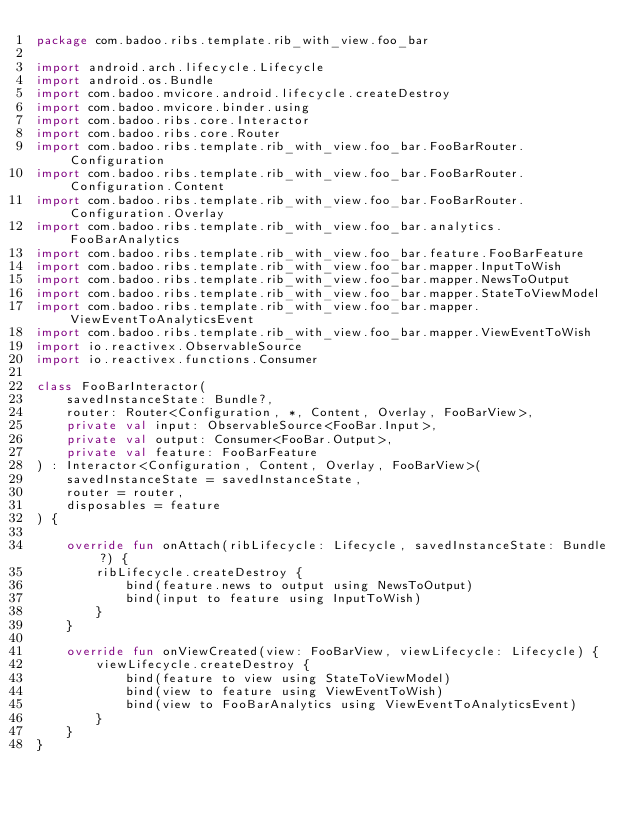Convert code to text. <code><loc_0><loc_0><loc_500><loc_500><_Kotlin_>package com.badoo.ribs.template.rib_with_view.foo_bar

import android.arch.lifecycle.Lifecycle
import android.os.Bundle
import com.badoo.mvicore.android.lifecycle.createDestroy
import com.badoo.mvicore.binder.using
import com.badoo.ribs.core.Interactor
import com.badoo.ribs.core.Router
import com.badoo.ribs.template.rib_with_view.foo_bar.FooBarRouter.Configuration
import com.badoo.ribs.template.rib_with_view.foo_bar.FooBarRouter.Configuration.Content
import com.badoo.ribs.template.rib_with_view.foo_bar.FooBarRouter.Configuration.Overlay
import com.badoo.ribs.template.rib_with_view.foo_bar.analytics.FooBarAnalytics
import com.badoo.ribs.template.rib_with_view.foo_bar.feature.FooBarFeature
import com.badoo.ribs.template.rib_with_view.foo_bar.mapper.InputToWish
import com.badoo.ribs.template.rib_with_view.foo_bar.mapper.NewsToOutput
import com.badoo.ribs.template.rib_with_view.foo_bar.mapper.StateToViewModel
import com.badoo.ribs.template.rib_with_view.foo_bar.mapper.ViewEventToAnalyticsEvent
import com.badoo.ribs.template.rib_with_view.foo_bar.mapper.ViewEventToWish
import io.reactivex.ObservableSource
import io.reactivex.functions.Consumer

class FooBarInteractor(
    savedInstanceState: Bundle?,
    router: Router<Configuration, *, Content, Overlay, FooBarView>,
    private val input: ObservableSource<FooBar.Input>,
    private val output: Consumer<FooBar.Output>,
    private val feature: FooBarFeature
) : Interactor<Configuration, Content, Overlay, FooBarView>(
    savedInstanceState = savedInstanceState,
    router = router,
    disposables = feature
) {

    override fun onAttach(ribLifecycle: Lifecycle, savedInstanceState: Bundle?) {
        ribLifecycle.createDestroy {
            bind(feature.news to output using NewsToOutput)
            bind(input to feature using InputToWish)
        }
    }

    override fun onViewCreated(view: FooBarView, viewLifecycle: Lifecycle) {
        viewLifecycle.createDestroy {
            bind(feature to view using StateToViewModel)
            bind(view to feature using ViewEventToWish)
            bind(view to FooBarAnalytics using ViewEventToAnalyticsEvent)
        }
    }
}
</code> 